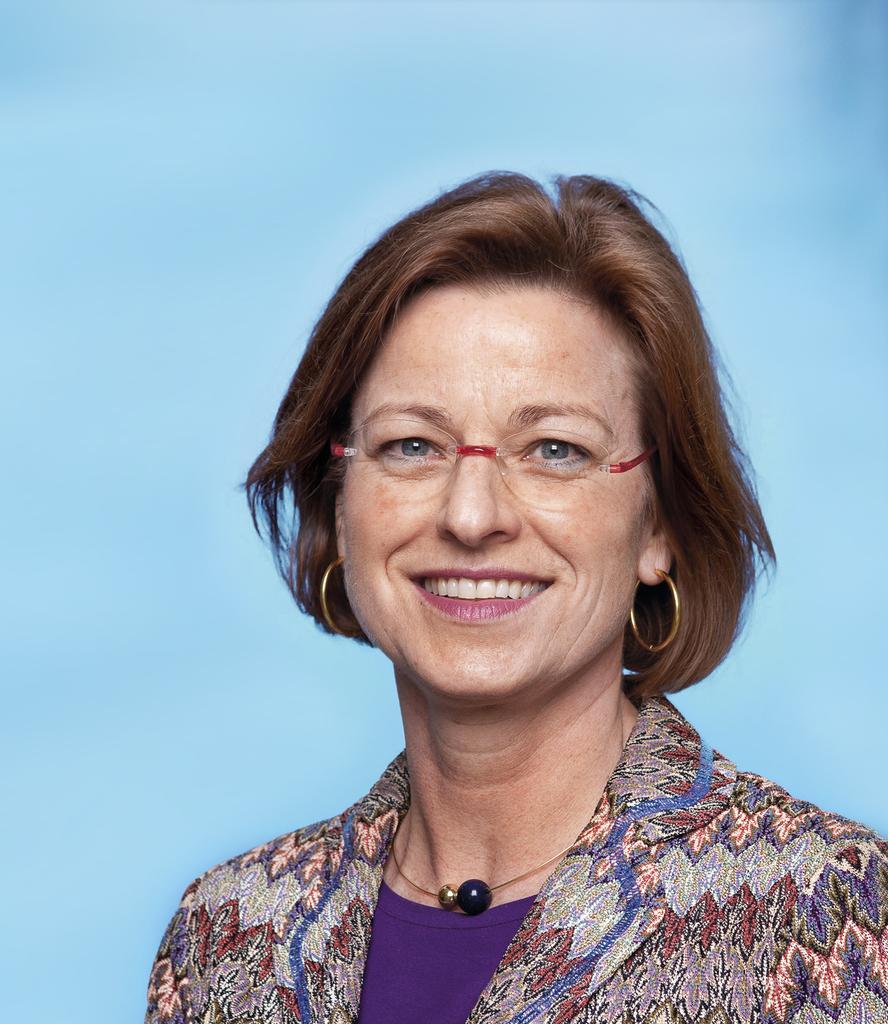Please provide a concise description of this image. In the foreground of this image, there is a woman having smile on her face and a sky blue background. 